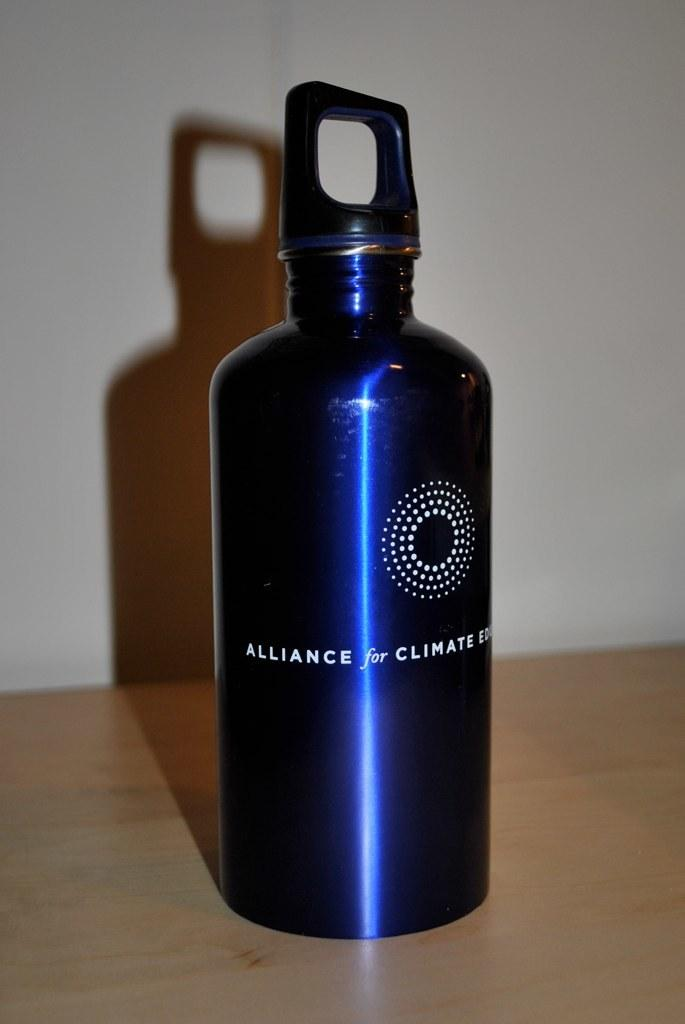<image>
Share a concise interpretation of the image provided. Alliance for climate blue water bottle sitting on a table 